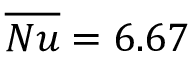<formula> <loc_0><loc_0><loc_500><loc_500>\overline { N u } = 6 . 6 7</formula> 